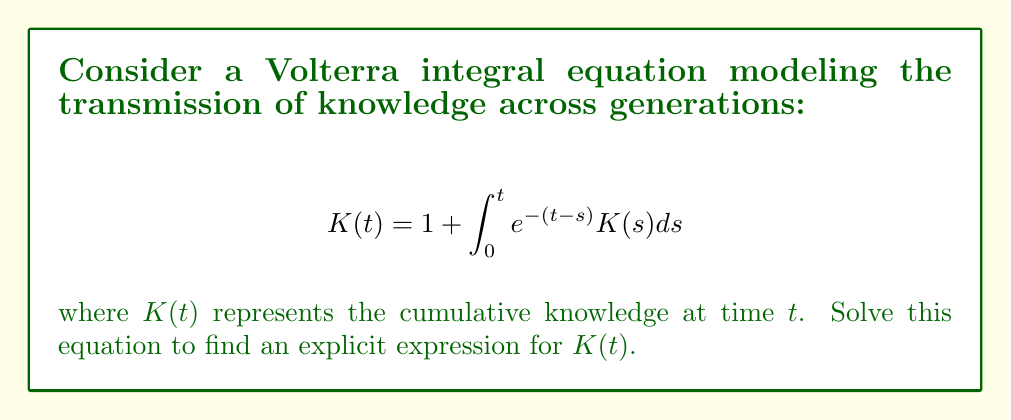Can you solve this math problem? To solve this Volterra integral equation, we'll follow these steps:

1) First, we differentiate both sides of the equation with respect to $t$:

   $$\frac{d}{dt}K(t) = \frac{d}{dt}\left(1 + \int_0^t e^{-(t-s)}K(s)ds\right)$$

2) Using the Leibniz rule for differentiating integrals:

   $$K'(t) = e^{-(t-t)}K(t) + \int_0^t \frac{d}{dt}(e^{-(t-s)})K(s)ds$$

3) Simplify:

   $$K'(t) = K(t) - \int_0^t e^{-(t-s)}K(s)ds$$

4) Substitute the original equation for the integral:

   $$K'(t) = K(t) - (K(t) - 1) = 1$$

5) We now have a simple differential equation:

   $$K'(t) = 1$$

6) Integrate both sides:

   $$K(t) = t + C$$

7) To find $C$, use the initial condition from the original equation ($K(0) = 1$):

   $$1 = 0 + C$$
   $$C = 1$$

8) Therefore, the solution is:

   $$K(t) = t + 1$$

9) Verify by substituting back into the original equation:

   $$t + 1 = 1 + \int_0^t e^{-(t-s)}(s + 1)ds$$

   $$t = \int_0^t e^{-(t-s)}(s + 1)ds$$

   This equality holds, confirming our solution.
Answer: $K(t) = t + 1$ 